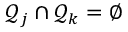Convert formula to latex. <formula><loc_0><loc_0><loc_500><loc_500>\mathcal { Q } _ { j } \cap \mathcal { Q } _ { k } = \emptyset</formula> 